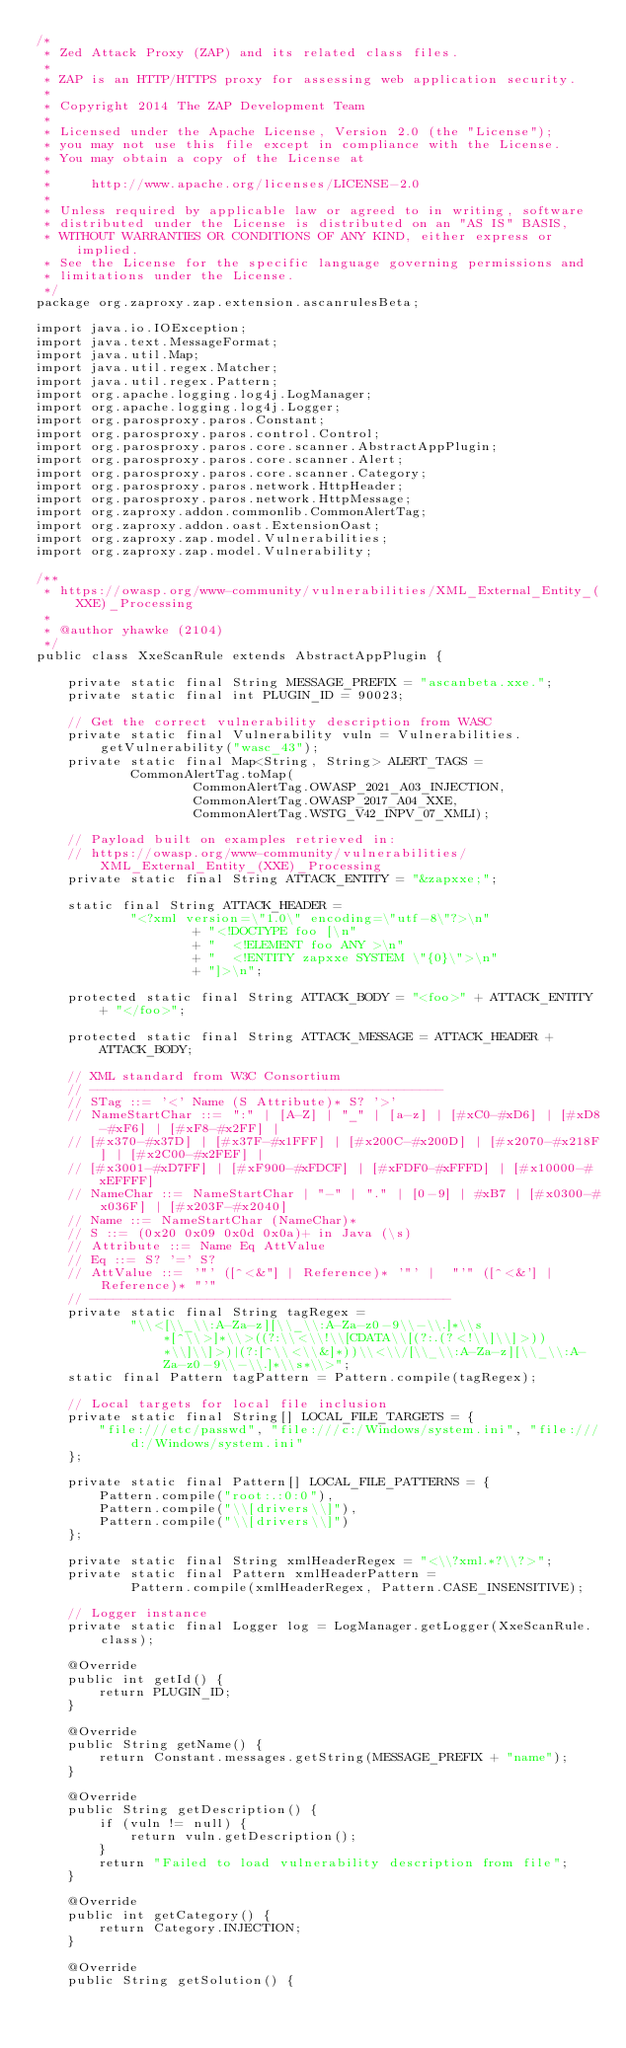Convert code to text. <code><loc_0><loc_0><loc_500><loc_500><_Java_>/*
 * Zed Attack Proxy (ZAP) and its related class files.
 *
 * ZAP is an HTTP/HTTPS proxy for assessing web application security.
 *
 * Copyright 2014 The ZAP Development Team
 *
 * Licensed under the Apache License, Version 2.0 (the "License");
 * you may not use this file except in compliance with the License.
 * You may obtain a copy of the License at
 *
 *     http://www.apache.org/licenses/LICENSE-2.0
 *
 * Unless required by applicable law or agreed to in writing, software
 * distributed under the License is distributed on an "AS IS" BASIS,
 * WITHOUT WARRANTIES OR CONDITIONS OF ANY KIND, either express or implied.
 * See the License for the specific language governing permissions and
 * limitations under the License.
 */
package org.zaproxy.zap.extension.ascanrulesBeta;

import java.io.IOException;
import java.text.MessageFormat;
import java.util.Map;
import java.util.regex.Matcher;
import java.util.regex.Pattern;
import org.apache.logging.log4j.LogManager;
import org.apache.logging.log4j.Logger;
import org.parosproxy.paros.Constant;
import org.parosproxy.paros.control.Control;
import org.parosproxy.paros.core.scanner.AbstractAppPlugin;
import org.parosproxy.paros.core.scanner.Alert;
import org.parosproxy.paros.core.scanner.Category;
import org.parosproxy.paros.network.HttpHeader;
import org.parosproxy.paros.network.HttpMessage;
import org.zaproxy.addon.commonlib.CommonAlertTag;
import org.zaproxy.addon.oast.ExtensionOast;
import org.zaproxy.zap.model.Vulnerabilities;
import org.zaproxy.zap.model.Vulnerability;

/**
 * https://owasp.org/www-community/vulnerabilities/XML_External_Entity_(XXE)_Processing
 *
 * @author yhawke (2104)
 */
public class XxeScanRule extends AbstractAppPlugin {

    private static final String MESSAGE_PREFIX = "ascanbeta.xxe.";
    private static final int PLUGIN_ID = 90023;

    // Get the correct vulnerability description from WASC
    private static final Vulnerability vuln = Vulnerabilities.getVulnerability("wasc_43");
    private static final Map<String, String> ALERT_TAGS =
            CommonAlertTag.toMap(
                    CommonAlertTag.OWASP_2021_A03_INJECTION,
                    CommonAlertTag.OWASP_2017_A04_XXE,
                    CommonAlertTag.WSTG_V42_INPV_07_XMLI);

    // Payload built on examples retrieved in:
    // https://owasp.org/www-community/vulnerabilities/XML_External_Entity_(XXE)_Processing
    private static final String ATTACK_ENTITY = "&zapxxe;";

    static final String ATTACK_HEADER =
            "<?xml version=\"1.0\" encoding=\"utf-8\"?>\n"
                    + "<!DOCTYPE foo [\n"
                    + "  <!ELEMENT foo ANY >\n"
                    + "  <!ENTITY zapxxe SYSTEM \"{0}\">\n"
                    + "]>\n";

    protected static final String ATTACK_BODY = "<foo>" + ATTACK_ENTITY + "</foo>";

    protected static final String ATTACK_MESSAGE = ATTACK_HEADER + ATTACK_BODY;

    // XML standard from W3C Consortium
    // ---------------------------------------------
    // STag ::= '<' Name (S Attribute)* S? '>'
    // NameStartChar ::= ":" | [A-Z] | "_" | [a-z] | [#xC0-#xD6] | [#xD8-#xF6] | [#xF8-#x2FF] |
    // [#x370-#x37D] | [#x37F-#x1FFF] | [#x200C-#x200D] | [#x2070-#x218F] | [#x2C00-#x2FEF] |
    // [#x3001-#xD7FF] | [#xF900-#xFDCF] | [#xFDF0-#xFFFD] | [#x10000-#xEFFFF]
    // NameChar ::= NameStartChar | "-" | "." | [0-9] | #xB7 | [#x0300-#x036F] | [#x203F-#x2040]
    // Name ::= NameStartChar (NameChar)*
    // S ::= (0x20 0x09 0x0d 0x0a)+ in Java (\s)
    // Attribute ::= Name Eq AttValue
    // Eq ::= S? '=' S?
    // AttValue ::= '"' ([^<&"] | Reference)* '"' |  "'" ([^<&'] | Reference)* "'"
    // ----------------------------------------------
    private static final String tagRegex =
            "\\<[\\_\\:A-Za-z][\\_\\:A-Za-z0-9\\-\\.]*\\s*[^\\>]*\\>((?:\\<\\!\\[CDATA\\[(?:.(?<!\\]\\]>))*\\]\\]>)|(?:[^\\<\\&]*))\\<\\/[\\_\\:A-Za-z][\\_\\:A-Za-z0-9\\-\\.]*\\s*\\>";
    static final Pattern tagPattern = Pattern.compile(tagRegex);

    // Local targets for local file inclusion
    private static final String[] LOCAL_FILE_TARGETS = {
        "file:///etc/passwd", "file:///c:/Windows/system.ini", "file:///d:/Windows/system.ini"
    };

    private static final Pattern[] LOCAL_FILE_PATTERNS = {
        Pattern.compile("root:.:0:0"),
        Pattern.compile("\\[drivers\\]"),
        Pattern.compile("\\[drivers\\]")
    };

    private static final String xmlHeaderRegex = "<\\?xml.*?\\?>";
    private static final Pattern xmlHeaderPattern =
            Pattern.compile(xmlHeaderRegex, Pattern.CASE_INSENSITIVE);

    // Logger instance
    private static final Logger log = LogManager.getLogger(XxeScanRule.class);

    @Override
    public int getId() {
        return PLUGIN_ID;
    }

    @Override
    public String getName() {
        return Constant.messages.getString(MESSAGE_PREFIX + "name");
    }

    @Override
    public String getDescription() {
        if (vuln != null) {
            return vuln.getDescription();
        }
        return "Failed to load vulnerability description from file";
    }

    @Override
    public int getCategory() {
        return Category.INJECTION;
    }

    @Override
    public String getSolution() {</code> 